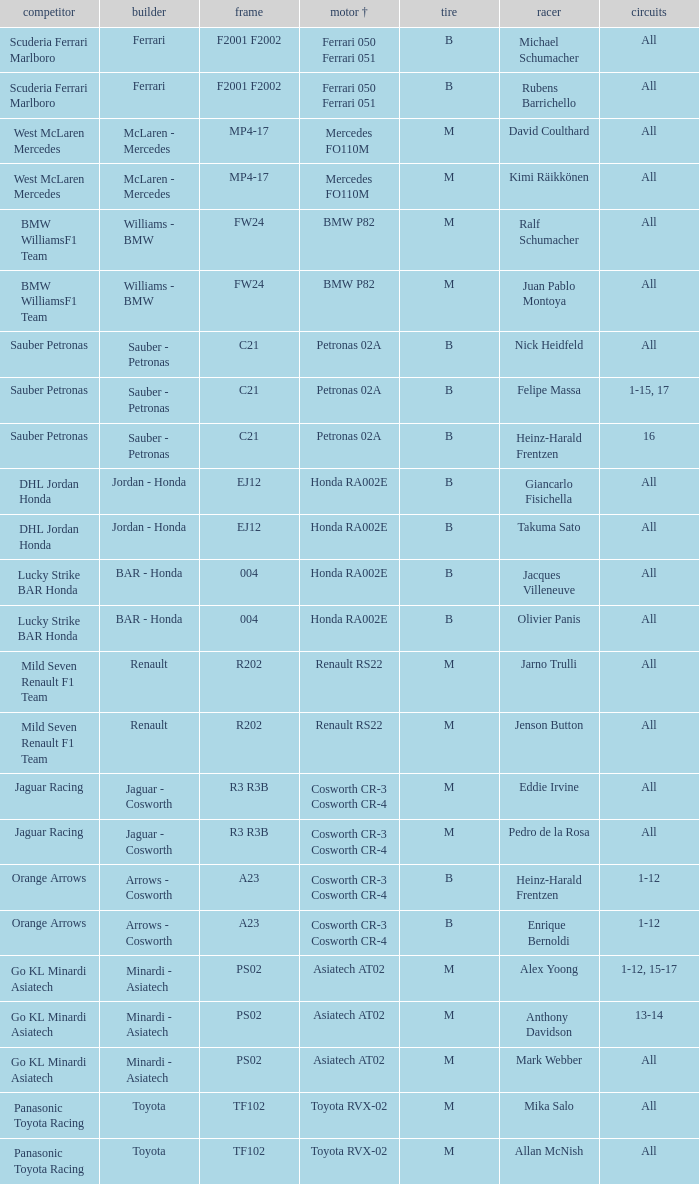What is the tyre when the engine is asiatech at02 and the driver is alex yoong? M. 